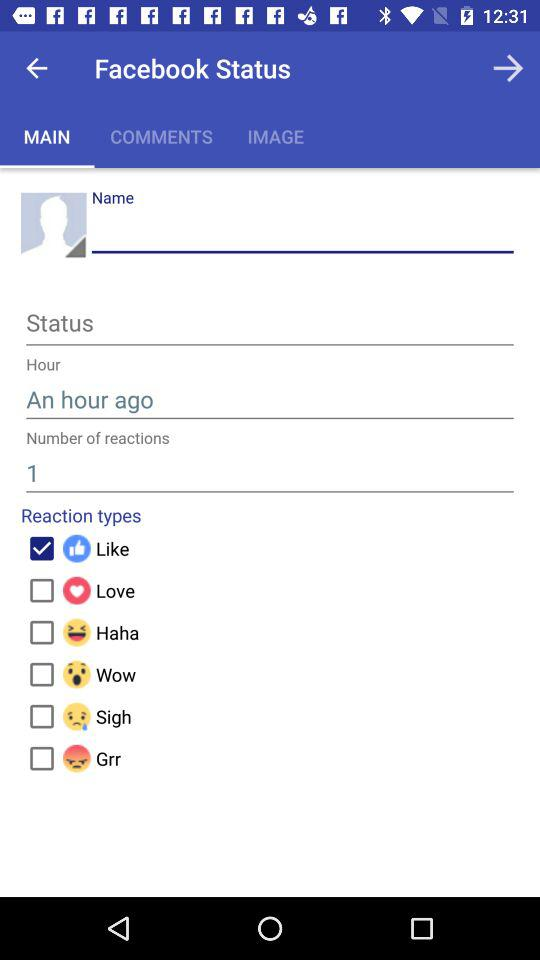How many reaction types are there?
Answer the question using a single word or phrase. 6 